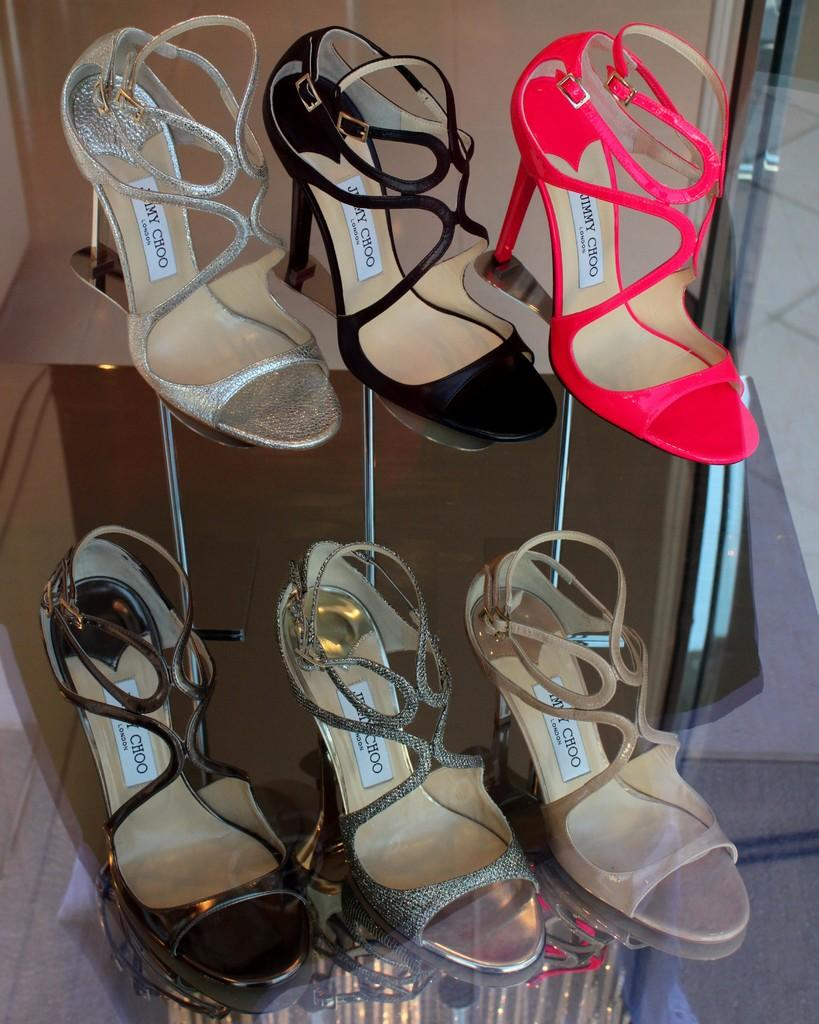What type of footwear is visible in the image? There are sandals in the image. Can you describe the appearance of the sandals? The sandals are in multiple colors. What is the color of the background in the image? The background of the image is brown. What type of joke is being told by the doll in the image? There is no doll present in the image, and therefore no joke-telling can be observed. What type of bread is visible in the image? There is no loaf of bread present in the image. 